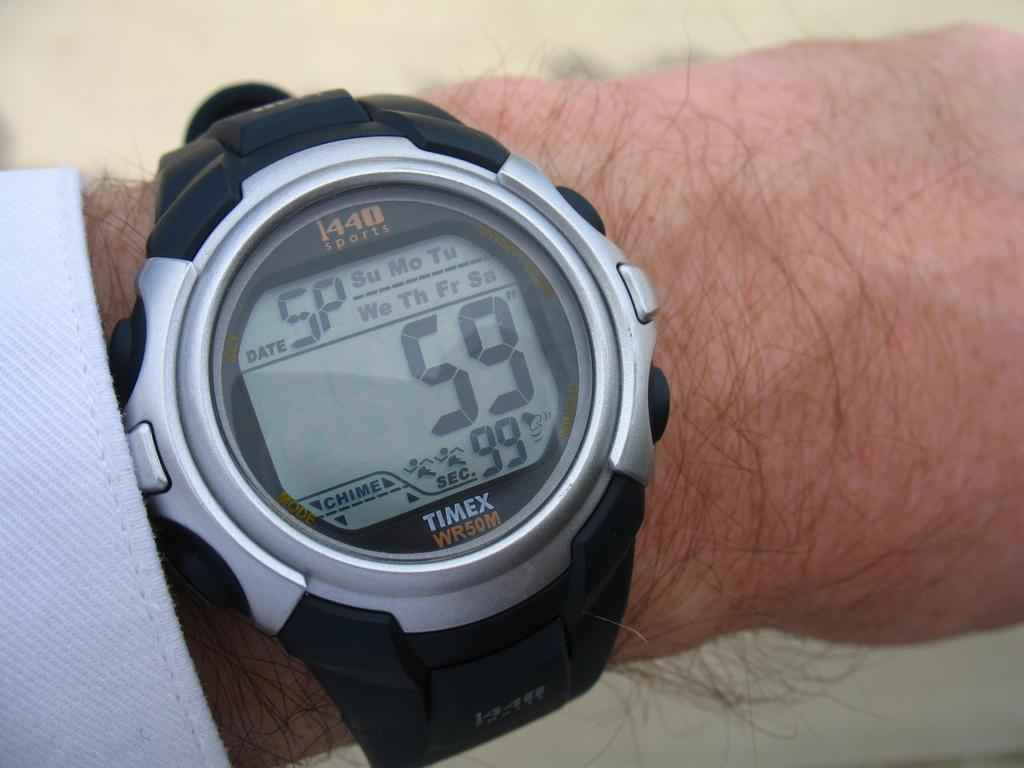<image>
Give a short and clear explanation of the subsequent image. A Timex watch with the number 59 on the face. 